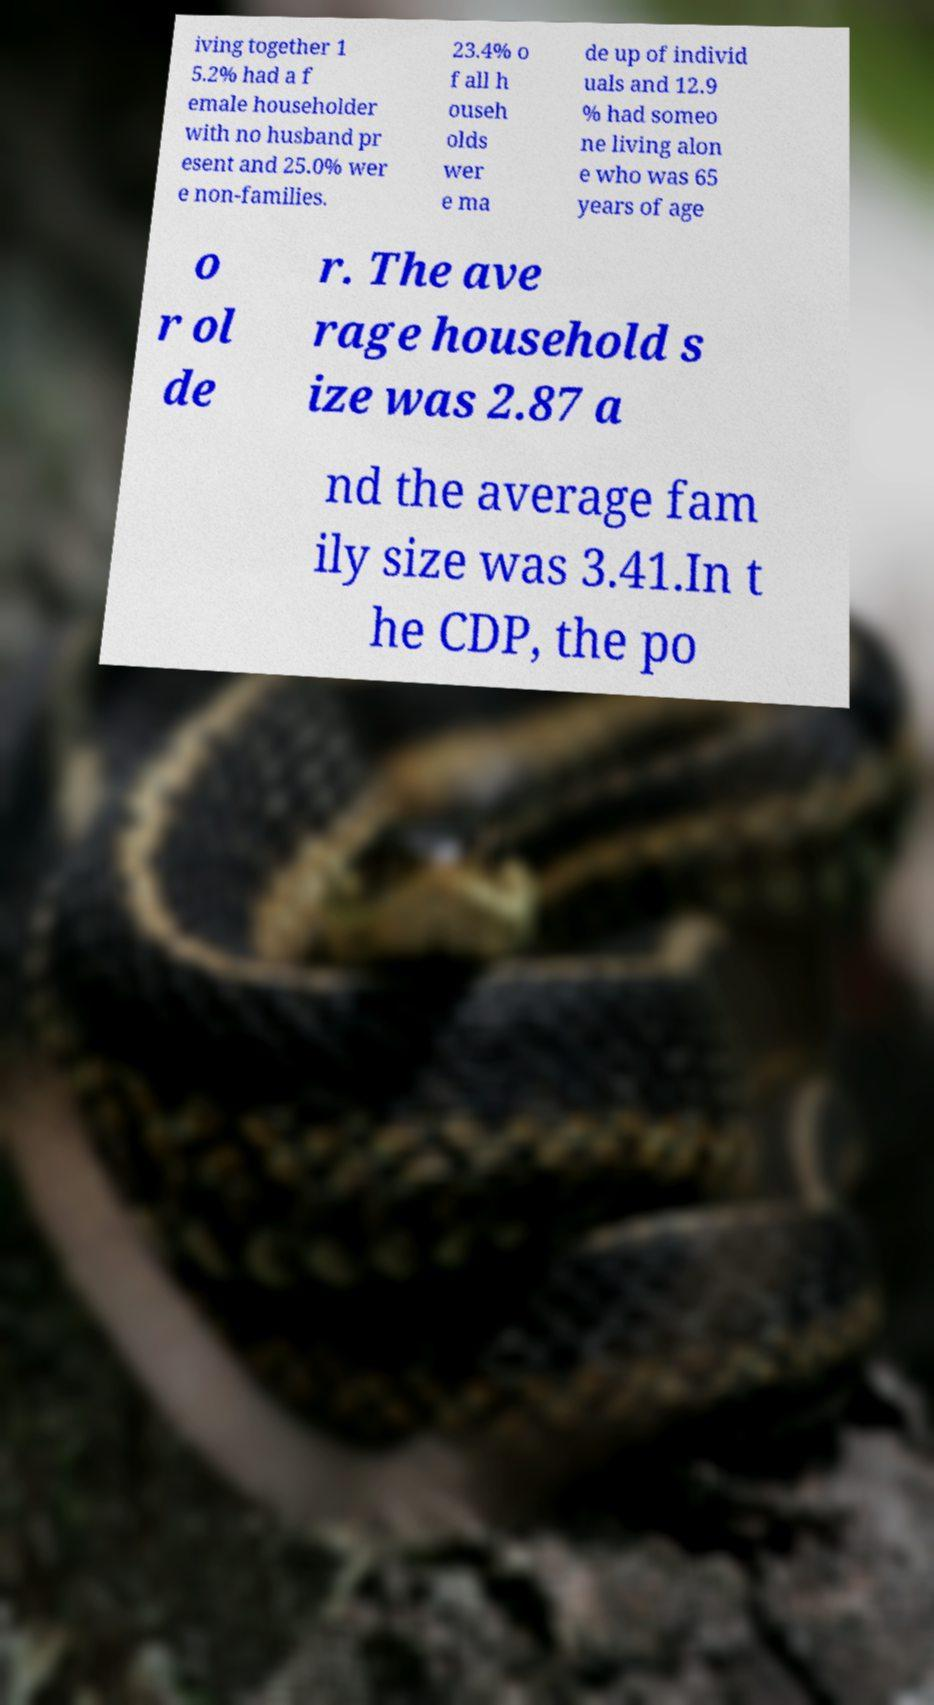For documentation purposes, I need the text within this image transcribed. Could you provide that? iving together 1 5.2% had a f emale householder with no husband pr esent and 25.0% wer e non-families. 23.4% o f all h ouseh olds wer e ma de up of individ uals and 12.9 % had someo ne living alon e who was 65 years of age o r ol de r. The ave rage household s ize was 2.87 a nd the average fam ily size was 3.41.In t he CDP, the po 